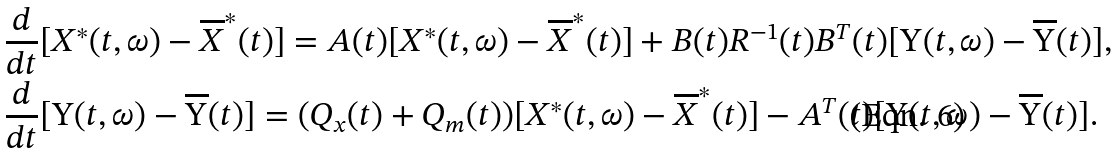<formula> <loc_0><loc_0><loc_500><loc_500>& \frac { d } { d t } [ X ^ { * } ( t , \omega ) - \overline { X } ^ { * } ( t ) ] = A ( t ) [ X ^ { * } ( t , \omega ) - \overline { X } ^ { * } ( t ) ] + B ( t ) R ^ { - 1 } ( t ) B ^ { T } ( t ) [ \Upsilon ( t , \omega ) - \overline { \Upsilon } ( t ) ] , \\ & \frac { d } { d t } [ \Upsilon ( t , \omega ) - \overline { \Upsilon } ( t ) ] = ( Q _ { x } ( t ) + Q _ { m } ( t ) ) [ X ^ { * } ( t , \omega ) - \overline { X } ^ { * } ( t ) ] - A ^ { T } ( t ) [ \Upsilon ( t , \omega ) - \overline { \Upsilon } ( t ) ] .</formula> 